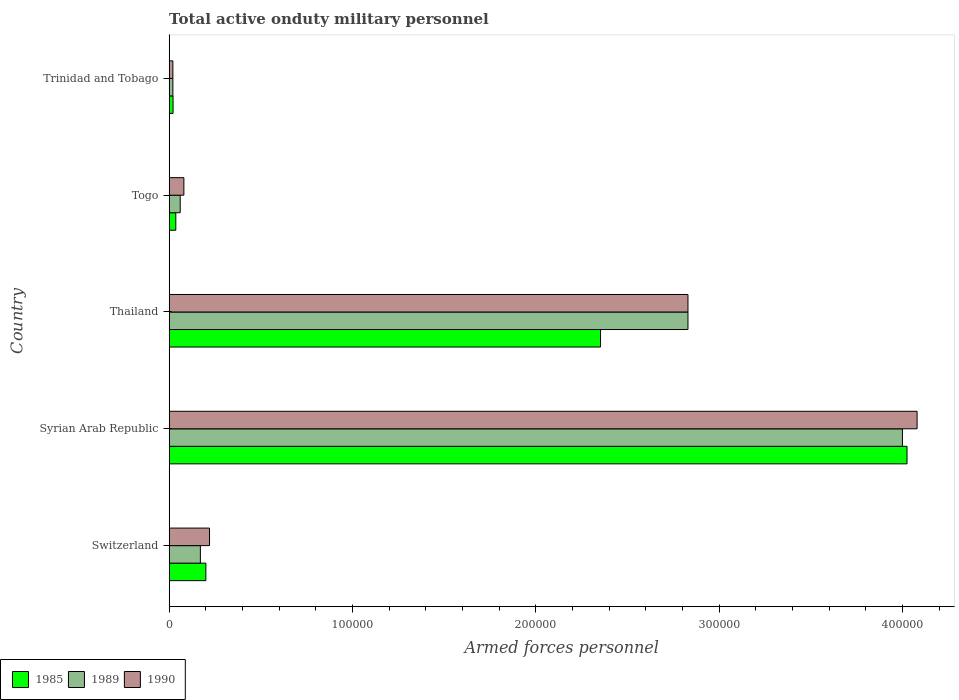How many different coloured bars are there?
Offer a terse response. 3. How many groups of bars are there?
Offer a very short reply. 5. Are the number of bars per tick equal to the number of legend labels?
Your response must be concise. Yes. Are the number of bars on each tick of the Y-axis equal?
Give a very brief answer. Yes. How many bars are there on the 3rd tick from the bottom?
Provide a succinct answer. 3. What is the label of the 4th group of bars from the top?
Ensure brevity in your answer.  Syrian Arab Republic. In how many cases, is the number of bars for a given country not equal to the number of legend labels?
Keep it short and to the point. 0. What is the number of armed forces personnel in 1989 in Togo?
Your answer should be very brief. 6000. Across all countries, what is the maximum number of armed forces personnel in 1989?
Offer a terse response. 4.00e+05. In which country was the number of armed forces personnel in 1989 maximum?
Your response must be concise. Syrian Arab Republic. In which country was the number of armed forces personnel in 1990 minimum?
Your answer should be very brief. Trinidad and Tobago. What is the total number of armed forces personnel in 1985 in the graph?
Your answer should be very brief. 6.64e+05. What is the difference between the number of armed forces personnel in 1985 in Switzerland and that in Trinidad and Tobago?
Make the answer very short. 1.79e+04. What is the difference between the number of armed forces personnel in 1990 in Togo and the number of armed forces personnel in 1989 in Syrian Arab Republic?
Your response must be concise. -3.92e+05. What is the average number of armed forces personnel in 1990 per country?
Your response must be concise. 1.45e+05. What is the difference between the number of armed forces personnel in 1990 and number of armed forces personnel in 1985 in Syrian Arab Republic?
Make the answer very short. 5500. What is the ratio of the number of armed forces personnel in 1985 in Syrian Arab Republic to that in Thailand?
Offer a very short reply. 1.71. Is the number of armed forces personnel in 1990 in Switzerland less than that in Thailand?
Offer a very short reply. Yes. Is the difference between the number of armed forces personnel in 1990 in Syrian Arab Republic and Thailand greater than the difference between the number of armed forces personnel in 1985 in Syrian Arab Republic and Thailand?
Your answer should be very brief. No. What is the difference between the highest and the second highest number of armed forces personnel in 1985?
Ensure brevity in your answer.  1.67e+05. What is the difference between the highest and the lowest number of armed forces personnel in 1985?
Ensure brevity in your answer.  4.00e+05. In how many countries, is the number of armed forces personnel in 1985 greater than the average number of armed forces personnel in 1985 taken over all countries?
Offer a very short reply. 2. What does the 2nd bar from the bottom in Syrian Arab Republic represents?
Provide a short and direct response. 1989. Is it the case that in every country, the sum of the number of armed forces personnel in 1990 and number of armed forces personnel in 1989 is greater than the number of armed forces personnel in 1985?
Your response must be concise. Yes. How many countries are there in the graph?
Your answer should be very brief. 5. What is the difference between two consecutive major ticks on the X-axis?
Make the answer very short. 1.00e+05. Does the graph contain grids?
Keep it short and to the point. No. How many legend labels are there?
Offer a very short reply. 3. What is the title of the graph?
Your answer should be compact. Total active onduty military personnel. What is the label or title of the X-axis?
Your response must be concise. Armed forces personnel. What is the label or title of the Y-axis?
Ensure brevity in your answer.  Country. What is the Armed forces personnel in 1985 in Switzerland?
Your response must be concise. 2.00e+04. What is the Armed forces personnel in 1989 in Switzerland?
Offer a terse response. 1.70e+04. What is the Armed forces personnel in 1990 in Switzerland?
Your answer should be compact. 2.20e+04. What is the Armed forces personnel of 1985 in Syrian Arab Republic?
Your answer should be compact. 4.02e+05. What is the Armed forces personnel in 1989 in Syrian Arab Republic?
Ensure brevity in your answer.  4.00e+05. What is the Armed forces personnel in 1990 in Syrian Arab Republic?
Offer a very short reply. 4.08e+05. What is the Armed forces personnel of 1985 in Thailand?
Make the answer very short. 2.35e+05. What is the Armed forces personnel of 1989 in Thailand?
Provide a short and direct response. 2.83e+05. What is the Armed forces personnel in 1990 in Thailand?
Keep it short and to the point. 2.83e+05. What is the Armed forces personnel of 1985 in Togo?
Give a very brief answer. 3600. What is the Armed forces personnel of 1989 in Togo?
Your response must be concise. 6000. What is the Armed forces personnel in 1990 in Togo?
Provide a succinct answer. 8000. What is the Armed forces personnel of 1985 in Trinidad and Tobago?
Offer a very short reply. 2100. What is the Armed forces personnel of 1989 in Trinidad and Tobago?
Your answer should be compact. 2000. What is the Armed forces personnel of 1990 in Trinidad and Tobago?
Your answer should be very brief. 2000. Across all countries, what is the maximum Armed forces personnel in 1985?
Make the answer very short. 4.02e+05. Across all countries, what is the maximum Armed forces personnel of 1990?
Your answer should be compact. 4.08e+05. Across all countries, what is the minimum Armed forces personnel in 1985?
Your answer should be very brief. 2100. What is the total Armed forces personnel in 1985 in the graph?
Ensure brevity in your answer.  6.64e+05. What is the total Armed forces personnel in 1989 in the graph?
Your response must be concise. 7.08e+05. What is the total Armed forces personnel in 1990 in the graph?
Make the answer very short. 7.23e+05. What is the difference between the Armed forces personnel of 1985 in Switzerland and that in Syrian Arab Republic?
Your response must be concise. -3.82e+05. What is the difference between the Armed forces personnel in 1989 in Switzerland and that in Syrian Arab Republic?
Your answer should be very brief. -3.83e+05. What is the difference between the Armed forces personnel in 1990 in Switzerland and that in Syrian Arab Republic?
Your response must be concise. -3.86e+05. What is the difference between the Armed forces personnel of 1985 in Switzerland and that in Thailand?
Your response must be concise. -2.15e+05. What is the difference between the Armed forces personnel of 1989 in Switzerland and that in Thailand?
Offer a very short reply. -2.66e+05. What is the difference between the Armed forces personnel of 1990 in Switzerland and that in Thailand?
Provide a short and direct response. -2.61e+05. What is the difference between the Armed forces personnel in 1985 in Switzerland and that in Togo?
Your answer should be compact. 1.64e+04. What is the difference between the Armed forces personnel in 1989 in Switzerland and that in Togo?
Offer a very short reply. 1.10e+04. What is the difference between the Armed forces personnel in 1990 in Switzerland and that in Togo?
Your answer should be compact. 1.40e+04. What is the difference between the Armed forces personnel in 1985 in Switzerland and that in Trinidad and Tobago?
Your answer should be compact. 1.79e+04. What is the difference between the Armed forces personnel in 1989 in Switzerland and that in Trinidad and Tobago?
Your answer should be very brief. 1.50e+04. What is the difference between the Armed forces personnel of 1985 in Syrian Arab Republic and that in Thailand?
Ensure brevity in your answer.  1.67e+05. What is the difference between the Armed forces personnel in 1989 in Syrian Arab Republic and that in Thailand?
Your answer should be compact. 1.17e+05. What is the difference between the Armed forces personnel of 1990 in Syrian Arab Republic and that in Thailand?
Your response must be concise. 1.25e+05. What is the difference between the Armed forces personnel of 1985 in Syrian Arab Republic and that in Togo?
Offer a very short reply. 3.99e+05. What is the difference between the Armed forces personnel of 1989 in Syrian Arab Republic and that in Togo?
Make the answer very short. 3.94e+05. What is the difference between the Armed forces personnel in 1985 in Syrian Arab Republic and that in Trinidad and Tobago?
Give a very brief answer. 4.00e+05. What is the difference between the Armed forces personnel of 1989 in Syrian Arab Republic and that in Trinidad and Tobago?
Your answer should be very brief. 3.98e+05. What is the difference between the Armed forces personnel in 1990 in Syrian Arab Republic and that in Trinidad and Tobago?
Offer a terse response. 4.06e+05. What is the difference between the Armed forces personnel in 1985 in Thailand and that in Togo?
Your response must be concise. 2.32e+05. What is the difference between the Armed forces personnel of 1989 in Thailand and that in Togo?
Your response must be concise. 2.77e+05. What is the difference between the Armed forces personnel in 1990 in Thailand and that in Togo?
Offer a very short reply. 2.75e+05. What is the difference between the Armed forces personnel in 1985 in Thailand and that in Trinidad and Tobago?
Your answer should be very brief. 2.33e+05. What is the difference between the Armed forces personnel in 1989 in Thailand and that in Trinidad and Tobago?
Offer a terse response. 2.81e+05. What is the difference between the Armed forces personnel of 1990 in Thailand and that in Trinidad and Tobago?
Ensure brevity in your answer.  2.81e+05. What is the difference between the Armed forces personnel of 1985 in Togo and that in Trinidad and Tobago?
Ensure brevity in your answer.  1500. What is the difference between the Armed forces personnel of 1989 in Togo and that in Trinidad and Tobago?
Make the answer very short. 4000. What is the difference between the Armed forces personnel in 1990 in Togo and that in Trinidad and Tobago?
Your response must be concise. 6000. What is the difference between the Armed forces personnel in 1985 in Switzerland and the Armed forces personnel in 1989 in Syrian Arab Republic?
Keep it short and to the point. -3.80e+05. What is the difference between the Armed forces personnel in 1985 in Switzerland and the Armed forces personnel in 1990 in Syrian Arab Republic?
Ensure brevity in your answer.  -3.88e+05. What is the difference between the Armed forces personnel of 1989 in Switzerland and the Armed forces personnel of 1990 in Syrian Arab Republic?
Your response must be concise. -3.91e+05. What is the difference between the Armed forces personnel of 1985 in Switzerland and the Armed forces personnel of 1989 in Thailand?
Your response must be concise. -2.63e+05. What is the difference between the Armed forces personnel in 1985 in Switzerland and the Armed forces personnel in 1990 in Thailand?
Provide a succinct answer. -2.63e+05. What is the difference between the Armed forces personnel of 1989 in Switzerland and the Armed forces personnel of 1990 in Thailand?
Make the answer very short. -2.66e+05. What is the difference between the Armed forces personnel of 1985 in Switzerland and the Armed forces personnel of 1989 in Togo?
Your answer should be very brief. 1.40e+04. What is the difference between the Armed forces personnel of 1985 in Switzerland and the Armed forces personnel of 1990 in Togo?
Provide a short and direct response. 1.20e+04. What is the difference between the Armed forces personnel of 1989 in Switzerland and the Armed forces personnel of 1990 in Togo?
Make the answer very short. 9000. What is the difference between the Armed forces personnel of 1985 in Switzerland and the Armed forces personnel of 1989 in Trinidad and Tobago?
Make the answer very short. 1.80e+04. What is the difference between the Armed forces personnel of 1985 in Switzerland and the Armed forces personnel of 1990 in Trinidad and Tobago?
Provide a short and direct response. 1.80e+04. What is the difference between the Armed forces personnel in 1989 in Switzerland and the Armed forces personnel in 1990 in Trinidad and Tobago?
Offer a terse response. 1.50e+04. What is the difference between the Armed forces personnel of 1985 in Syrian Arab Republic and the Armed forces personnel of 1989 in Thailand?
Provide a succinct answer. 1.20e+05. What is the difference between the Armed forces personnel of 1985 in Syrian Arab Republic and the Armed forces personnel of 1990 in Thailand?
Provide a short and direct response. 1.20e+05. What is the difference between the Armed forces personnel in 1989 in Syrian Arab Republic and the Armed forces personnel in 1990 in Thailand?
Give a very brief answer. 1.17e+05. What is the difference between the Armed forces personnel in 1985 in Syrian Arab Republic and the Armed forces personnel in 1989 in Togo?
Your answer should be very brief. 3.96e+05. What is the difference between the Armed forces personnel of 1985 in Syrian Arab Republic and the Armed forces personnel of 1990 in Togo?
Your answer should be compact. 3.94e+05. What is the difference between the Armed forces personnel in 1989 in Syrian Arab Republic and the Armed forces personnel in 1990 in Togo?
Your answer should be compact. 3.92e+05. What is the difference between the Armed forces personnel of 1985 in Syrian Arab Republic and the Armed forces personnel of 1989 in Trinidad and Tobago?
Your response must be concise. 4.00e+05. What is the difference between the Armed forces personnel of 1985 in Syrian Arab Republic and the Armed forces personnel of 1990 in Trinidad and Tobago?
Your response must be concise. 4.00e+05. What is the difference between the Armed forces personnel of 1989 in Syrian Arab Republic and the Armed forces personnel of 1990 in Trinidad and Tobago?
Give a very brief answer. 3.98e+05. What is the difference between the Armed forces personnel of 1985 in Thailand and the Armed forces personnel of 1989 in Togo?
Your answer should be compact. 2.29e+05. What is the difference between the Armed forces personnel of 1985 in Thailand and the Armed forces personnel of 1990 in Togo?
Make the answer very short. 2.27e+05. What is the difference between the Armed forces personnel of 1989 in Thailand and the Armed forces personnel of 1990 in Togo?
Ensure brevity in your answer.  2.75e+05. What is the difference between the Armed forces personnel of 1985 in Thailand and the Armed forces personnel of 1989 in Trinidad and Tobago?
Give a very brief answer. 2.33e+05. What is the difference between the Armed forces personnel of 1985 in Thailand and the Armed forces personnel of 1990 in Trinidad and Tobago?
Your answer should be compact. 2.33e+05. What is the difference between the Armed forces personnel in 1989 in Thailand and the Armed forces personnel in 1990 in Trinidad and Tobago?
Your response must be concise. 2.81e+05. What is the difference between the Armed forces personnel in 1985 in Togo and the Armed forces personnel in 1989 in Trinidad and Tobago?
Your answer should be very brief. 1600. What is the difference between the Armed forces personnel in 1985 in Togo and the Armed forces personnel in 1990 in Trinidad and Tobago?
Give a very brief answer. 1600. What is the difference between the Armed forces personnel in 1989 in Togo and the Armed forces personnel in 1990 in Trinidad and Tobago?
Offer a very short reply. 4000. What is the average Armed forces personnel of 1985 per country?
Provide a short and direct response. 1.33e+05. What is the average Armed forces personnel in 1989 per country?
Keep it short and to the point. 1.42e+05. What is the average Armed forces personnel of 1990 per country?
Keep it short and to the point. 1.45e+05. What is the difference between the Armed forces personnel in 1985 and Armed forces personnel in 1989 in Switzerland?
Offer a very short reply. 3000. What is the difference between the Armed forces personnel of 1985 and Armed forces personnel of 1990 in Switzerland?
Your answer should be very brief. -2000. What is the difference between the Armed forces personnel of 1989 and Armed forces personnel of 1990 in Switzerland?
Offer a very short reply. -5000. What is the difference between the Armed forces personnel of 1985 and Armed forces personnel of 1989 in Syrian Arab Republic?
Keep it short and to the point. 2500. What is the difference between the Armed forces personnel of 1985 and Armed forces personnel of 1990 in Syrian Arab Republic?
Make the answer very short. -5500. What is the difference between the Armed forces personnel in 1989 and Armed forces personnel in 1990 in Syrian Arab Republic?
Offer a terse response. -8000. What is the difference between the Armed forces personnel in 1985 and Armed forces personnel in 1989 in Thailand?
Give a very brief answer. -4.77e+04. What is the difference between the Armed forces personnel of 1985 and Armed forces personnel of 1990 in Thailand?
Make the answer very short. -4.77e+04. What is the difference between the Armed forces personnel of 1989 and Armed forces personnel of 1990 in Thailand?
Provide a short and direct response. 0. What is the difference between the Armed forces personnel of 1985 and Armed forces personnel of 1989 in Togo?
Keep it short and to the point. -2400. What is the difference between the Armed forces personnel of 1985 and Armed forces personnel of 1990 in Togo?
Keep it short and to the point. -4400. What is the difference between the Armed forces personnel in 1989 and Armed forces personnel in 1990 in Togo?
Your response must be concise. -2000. What is the difference between the Armed forces personnel in 1985 and Armed forces personnel in 1989 in Trinidad and Tobago?
Your answer should be compact. 100. What is the ratio of the Armed forces personnel in 1985 in Switzerland to that in Syrian Arab Republic?
Provide a short and direct response. 0.05. What is the ratio of the Armed forces personnel of 1989 in Switzerland to that in Syrian Arab Republic?
Offer a very short reply. 0.04. What is the ratio of the Armed forces personnel of 1990 in Switzerland to that in Syrian Arab Republic?
Offer a very short reply. 0.05. What is the ratio of the Armed forces personnel in 1985 in Switzerland to that in Thailand?
Your answer should be very brief. 0.09. What is the ratio of the Armed forces personnel in 1989 in Switzerland to that in Thailand?
Offer a terse response. 0.06. What is the ratio of the Armed forces personnel in 1990 in Switzerland to that in Thailand?
Offer a very short reply. 0.08. What is the ratio of the Armed forces personnel in 1985 in Switzerland to that in Togo?
Your response must be concise. 5.56. What is the ratio of the Armed forces personnel of 1989 in Switzerland to that in Togo?
Offer a terse response. 2.83. What is the ratio of the Armed forces personnel of 1990 in Switzerland to that in Togo?
Provide a succinct answer. 2.75. What is the ratio of the Armed forces personnel in 1985 in Switzerland to that in Trinidad and Tobago?
Provide a succinct answer. 9.52. What is the ratio of the Armed forces personnel in 1989 in Switzerland to that in Trinidad and Tobago?
Your answer should be very brief. 8.5. What is the ratio of the Armed forces personnel in 1985 in Syrian Arab Republic to that in Thailand?
Provide a succinct answer. 1.71. What is the ratio of the Armed forces personnel in 1989 in Syrian Arab Republic to that in Thailand?
Keep it short and to the point. 1.41. What is the ratio of the Armed forces personnel of 1990 in Syrian Arab Republic to that in Thailand?
Your answer should be compact. 1.44. What is the ratio of the Armed forces personnel in 1985 in Syrian Arab Republic to that in Togo?
Offer a terse response. 111.81. What is the ratio of the Armed forces personnel of 1989 in Syrian Arab Republic to that in Togo?
Provide a short and direct response. 66.67. What is the ratio of the Armed forces personnel of 1985 in Syrian Arab Republic to that in Trinidad and Tobago?
Your answer should be very brief. 191.67. What is the ratio of the Armed forces personnel in 1989 in Syrian Arab Republic to that in Trinidad and Tobago?
Provide a succinct answer. 200. What is the ratio of the Armed forces personnel of 1990 in Syrian Arab Republic to that in Trinidad and Tobago?
Provide a short and direct response. 204. What is the ratio of the Armed forces personnel in 1985 in Thailand to that in Togo?
Keep it short and to the point. 65.36. What is the ratio of the Armed forces personnel of 1989 in Thailand to that in Togo?
Make the answer very short. 47.17. What is the ratio of the Armed forces personnel of 1990 in Thailand to that in Togo?
Provide a short and direct response. 35.38. What is the ratio of the Armed forces personnel in 1985 in Thailand to that in Trinidad and Tobago?
Provide a succinct answer. 112.05. What is the ratio of the Armed forces personnel of 1989 in Thailand to that in Trinidad and Tobago?
Give a very brief answer. 141.5. What is the ratio of the Armed forces personnel in 1990 in Thailand to that in Trinidad and Tobago?
Offer a very short reply. 141.5. What is the ratio of the Armed forces personnel of 1985 in Togo to that in Trinidad and Tobago?
Offer a terse response. 1.71. What is the ratio of the Armed forces personnel in 1989 in Togo to that in Trinidad and Tobago?
Make the answer very short. 3. What is the ratio of the Armed forces personnel in 1990 in Togo to that in Trinidad and Tobago?
Provide a short and direct response. 4. What is the difference between the highest and the second highest Armed forces personnel of 1985?
Your answer should be compact. 1.67e+05. What is the difference between the highest and the second highest Armed forces personnel of 1989?
Provide a short and direct response. 1.17e+05. What is the difference between the highest and the second highest Armed forces personnel in 1990?
Make the answer very short. 1.25e+05. What is the difference between the highest and the lowest Armed forces personnel in 1985?
Offer a very short reply. 4.00e+05. What is the difference between the highest and the lowest Armed forces personnel in 1989?
Ensure brevity in your answer.  3.98e+05. What is the difference between the highest and the lowest Armed forces personnel in 1990?
Your answer should be compact. 4.06e+05. 